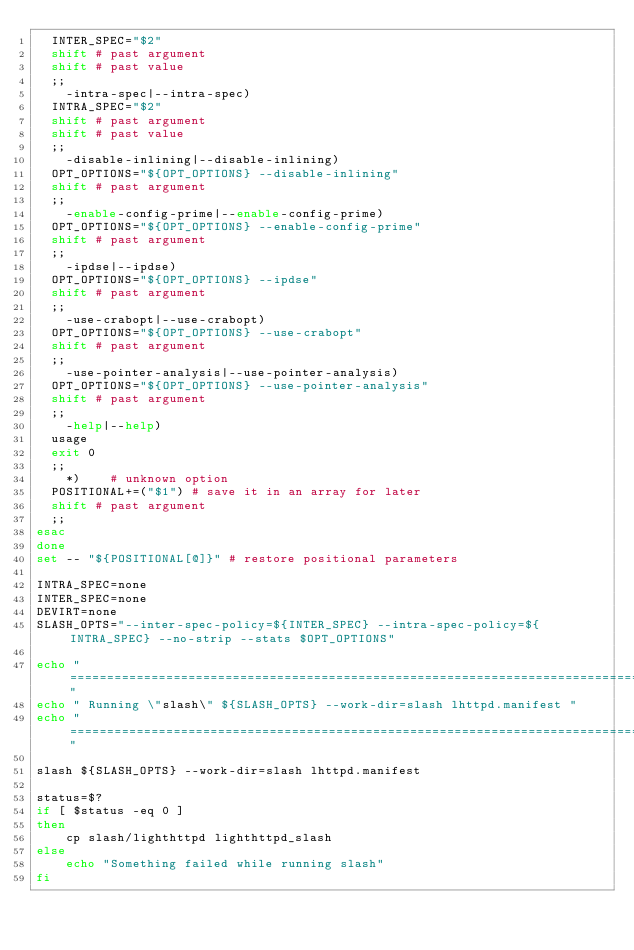<code> <loc_0><loc_0><loc_500><loc_500><_Bash_>	INTER_SPEC="$2"
	shift # past argument
	shift # past value
	;;
    -intra-spec|--intra-spec)
	INTRA_SPEC="$2"
	shift # past argument
	shift # past value
	;;
    -disable-inlining|--disable-inlining)
	OPT_OPTIONS="${OPT_OPTIONS} --disable-inlining"
	shift # past argument
	;;
    -enable-config-prime|--enable-config-prime)
	OPT_OPTIONS="${OPT_OPTIONS} --enable-config-prime"
	shift # past argument
	;;
    -ipdse|--ipdse)
	OPT_OPTIONS="${OPT_OPTIONS} --ipdse"
	shift # past argument
	;;
    -use-crabopt|--use-crabopt)
	OPT_OPTIONS="${OPT_OPTIONS} --use-crabopt"
	shift # past argument
	;;
    -use-pointer-analysis|--use-pointer-analysis)
	OPT_OPTIONS="${OPT_OPTIONS} --use-pointer-analysis"
	shift # past argument
	;;    
    -help|--help)
	usage
	exit 0
	;;
    *)    # unknown option
	POSITIONAL+=("$1") # save it in an array for later
	shift # past argument
	;;
esac
done
set -- "${POSITIONAL[@]}" # restore positional parameters

INTRA_SPEC=none
INTER_SPEC=none
DEVIRT=none
SLASH_OPTS="--inter-spec-policy=${INTER_SPEC} --intra-spec-policy=${INTRA_SPEC} --no-strip --stats $OPT_OPTIONS"

echo "=================================================================================="
echo " Running \"slash\" ${SLASH_OPTS} --work-dir=slash lhttpd.manifest "
echo "=================================================================================="

slash ${SLASH_OPTS} --work-dir=slash lhttpd.manifest 

status=$?
if [ $status -eq 0 ]
then
    cp slash/lighthttpd lighthttpd_slash
else
    echo "Something failed while running slash"
fi    
</code> 